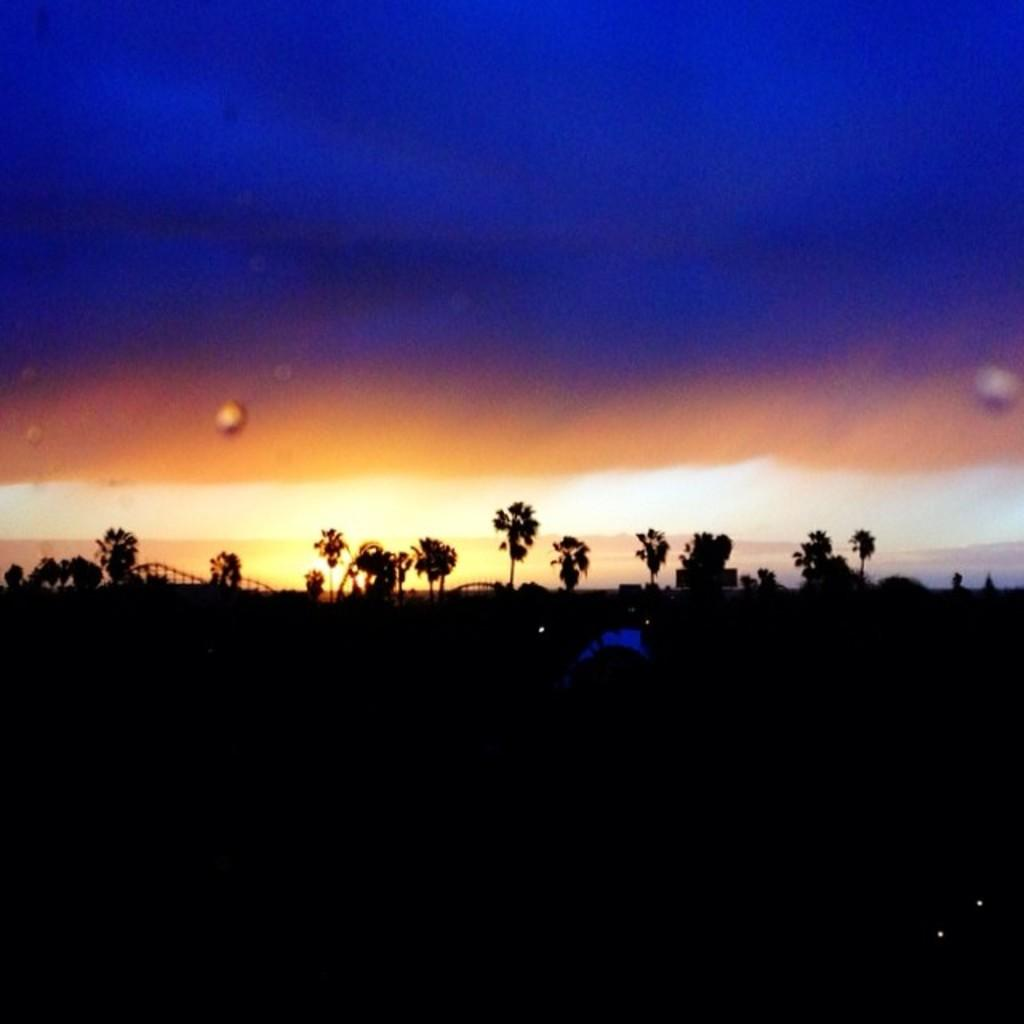What type of vegetation can be seen in the image? There are trees in the image. What else is present in the image besides trees? There are objects in the image. What can be seen above the trees and objects in the image? The sky is visible in the image. Are there any dolls playing in the snow in the image? There is no snow or dolls present in the image. 